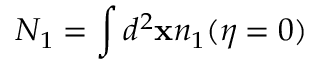Convert formula to latex. <formula><loc_0><loc_0><loc_500><loc_500>N _ { 1 } = \int d ^ { 2 } x n _ { 1 } ( \eta = 0 )</formula> 